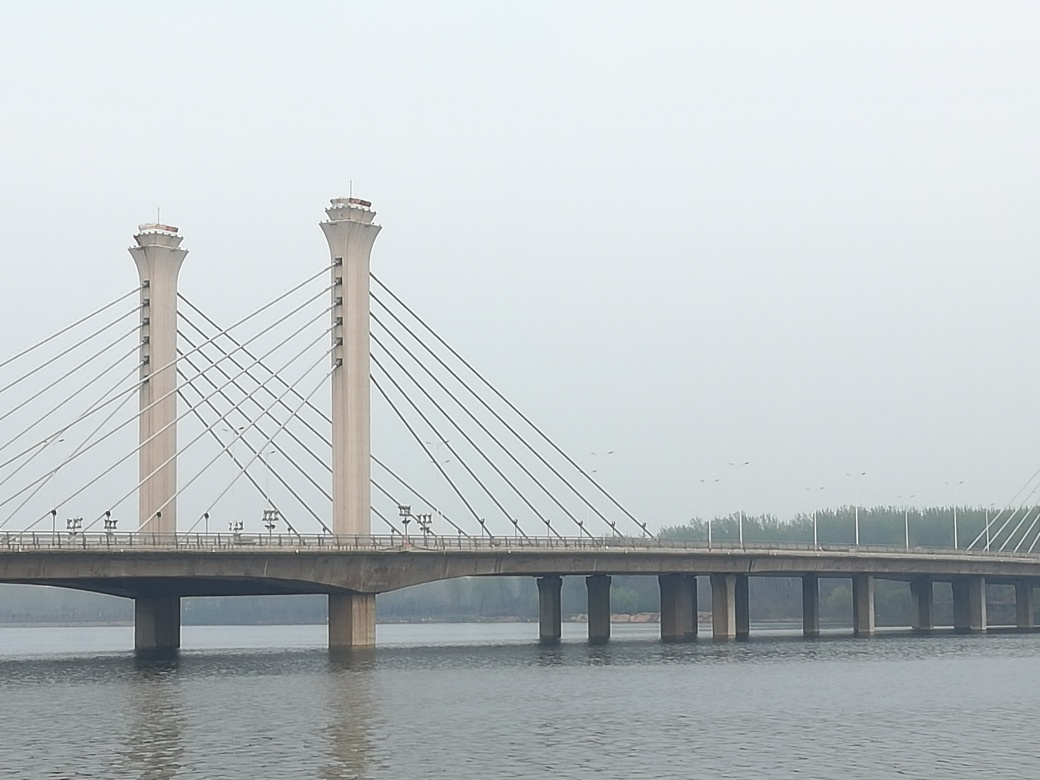What is the overall clarity of the image? The image is relatively clear with no obvious distortions or blurring. The details on the bridge, such as its towers, cables, and the roadway, are visible. However, the atmosphere appears slightly hazy, possibly due to weather conditions like fog or pollution, which mildly affects the sharpness and color saturation of the distant scenery. 